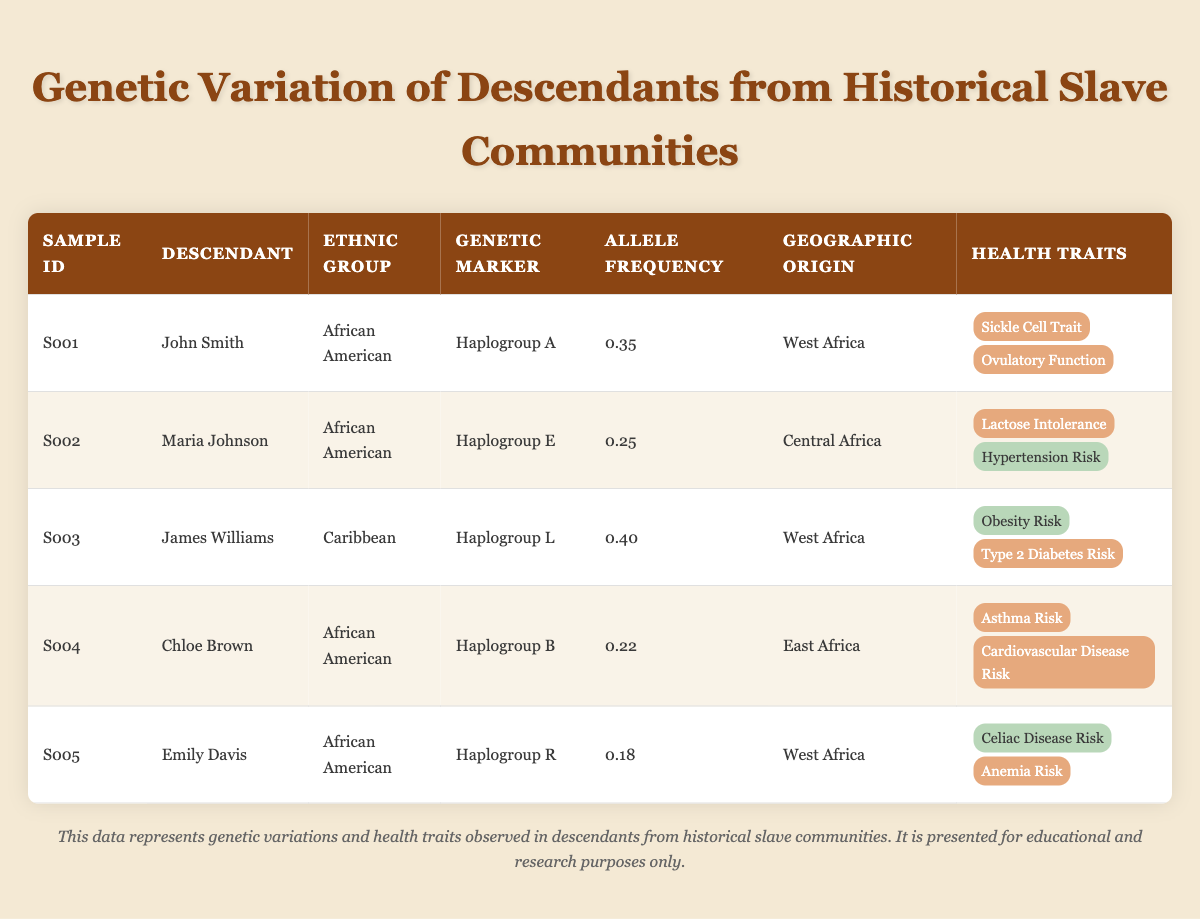What is the ethnic group of John Smith? The table lists John Smith's ethnic group in the Ethnic Group column. It states clearly that his ethnic group is African American.
Answer: African American Which descendant has the highest allele frequency? By reviewing the Allele Frequency column, we observe the values: 0.35 (John Smith), 0.25 (Maria Johnson), 0.40 (James Williams), 0.22 (Chloe Brown), and 0.18 (Emily Davis). The highest value is 0.40, corresponding to James Williams.
Answer: James Williams Is Emily Davis at risk for celiac disease? To answer this, we look at Emily Davis' health traits. In the Health Traits column, it shows that the presence of Celiac Disease Risk for her is marked as false (absent).
Answer: No What percentage of the descendants listed have Sickle Cell Trait? There are 5 descendants total. From the Health Traits column, only John Smith is marked as having Sickle Cell Trait (true). Thus, the calculation is (1/5) * 100 = 20%.
Answer: 20% Which genetic markers are associated with asthma risk? The Health Traits column must be examined for all descendants, specifically looking for the presence of Asthma Risk. According to the table, only Chloe Brown has a risk for asthma, and her genetic marker is Haplogroup B. Thus, Haplogroup B is associated with asthma risk.
Answer: Haplogroup B What is the average allele frequency for the African American descendants shown? First, we identify the descendants classified as African American: John Smith (0.35), Maria Johnson (0.25), and Chloe Brown (0.22). We sum these values: 0.35 + 0.25 + 0.22 = 0.82. Since there are 3 values, we divide by 3 to find the average: 0.82 / 3 ≈ 0.2733.
Answer: 0.2733 Does James Williams have a risk of obesity? In the Health Traits column for James Williams, the risk for obesity is marked as absent (false). Thus, he does not have a risk of obesity.
Answer: No Which descendant has the highest risk for Type 2 Diabetes? Looking at the Health Traits column, James Williams is the only one marked as having Type 2 Diabetes Risk present (true). Thus, he has the highest risk for this trait among the listed descendants.
Answer: James Williams How many descendants are indicated to have anemia risk? We refer to the Health Traits column to count the number of descendants with anemia risk. In this case, only Emily Davis is marked as having Anemia Risk present (true). Thus, the total count is one.
Answer: 1 